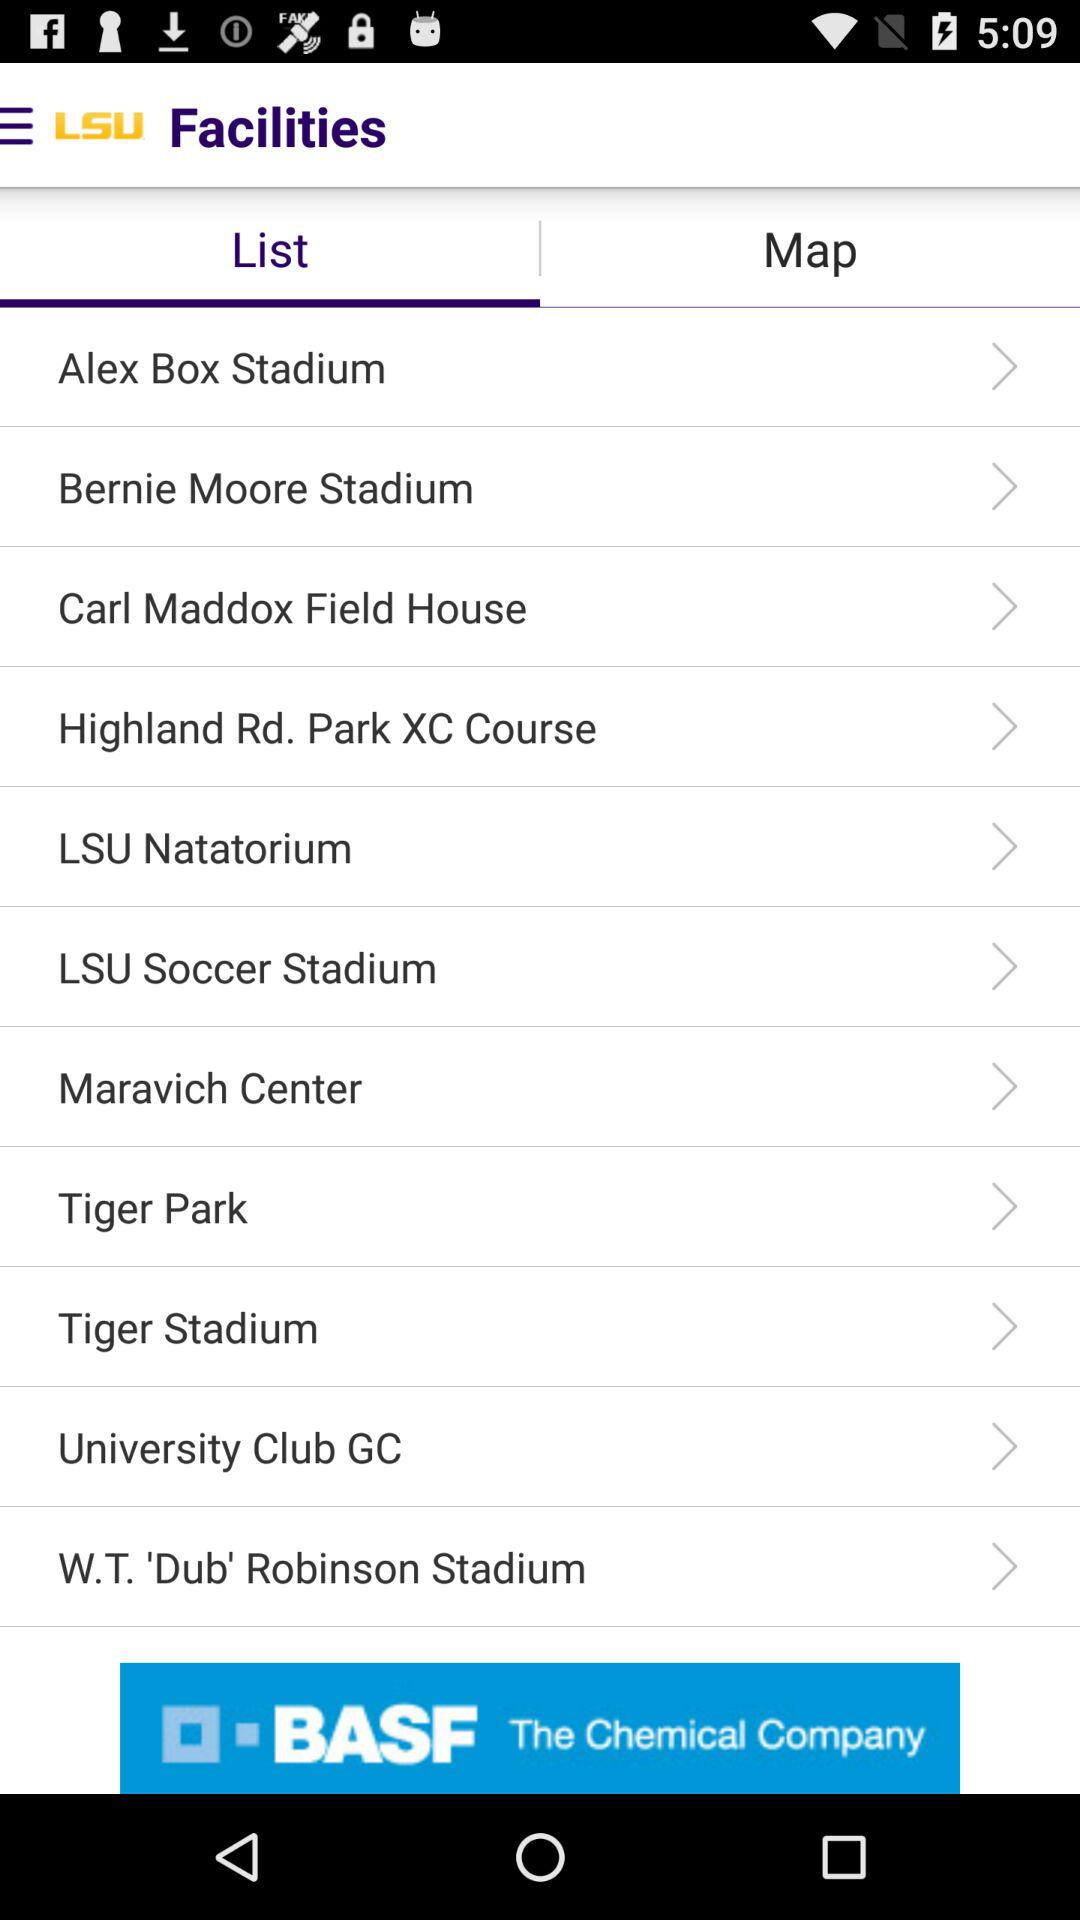What is the application name? The application name is "LSU Facilities". 